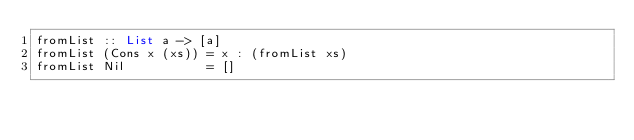Convert code to text. <code><loc_0><loc_0><loc_500><loc_500><_Haskell_>fromList :: List a -> [a]
fromList (Cons x (xs)) = x : (fromList xs)
fromList Nil           = [] </code> 